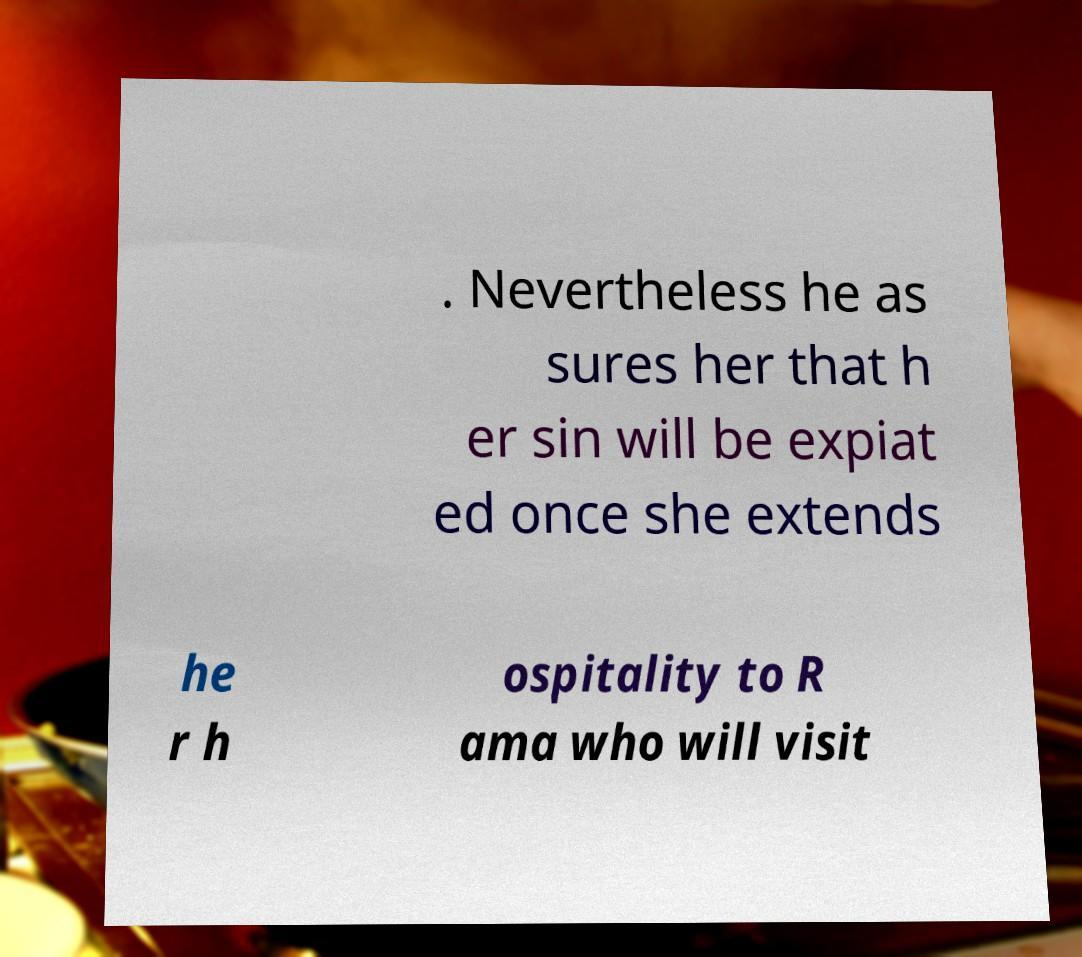Could you assist in decoding the text presented in this image and type it out clearly? . Nevertheless he as sures her that h er sin will be expiat ed once she extends he r h ospitality to R ama who will visit 